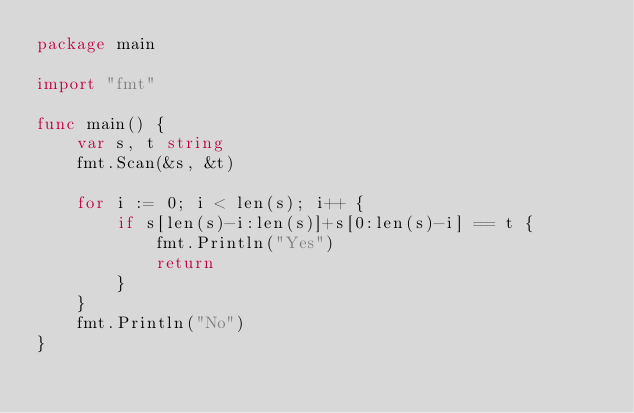Convert code to text. <code><loc_0><loc_0><loc_500><loc_500><_Go_>package main

import "fmt"

func main() {
	var s, t string
	fmt.Scan(&s, &t)

	for i := 0; i < len(s); i++ {
		if s[len(s)-i:len(s)]+s[0:len(s)-i] == t {
			fmt.Println("Yes")
			return
		}
	}
	fmt.Println("No")
}
</code> 